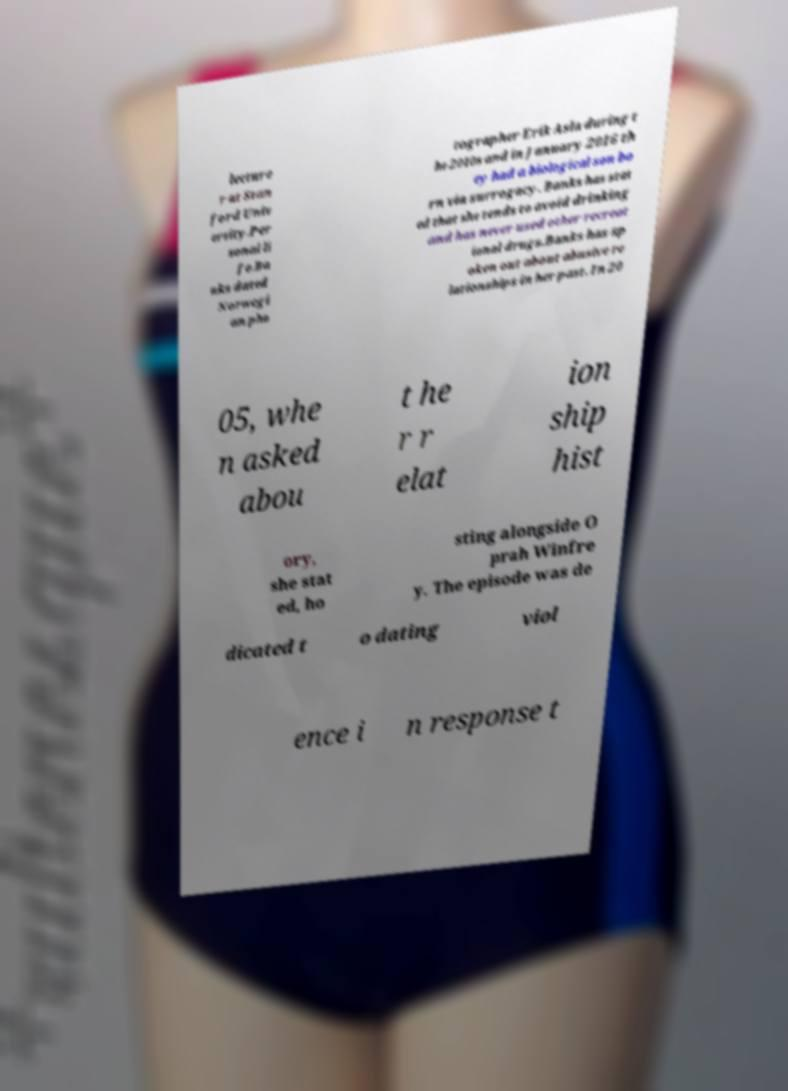Can you read and provide the text displayed in the image?This photo seems to have some interesting text. Can you extract and type it out for me? lecture r at Stan ford Univ ersity.Per sonal li fe.Ba nks dated Norwegi an pho tographer Erik Asla during t he 2010s and in January 2016 th ey had a biological son bo rn via surrogacy. Banks has stat ed that she tends to avoid drinking and has never used other recreat ional drugs.Banks has sp oken out about abusive re lationships in her past. In 20 05, whe n asked abou t he r r elat ion ship hist ory, she stat ed, ho sting alongside O prah Winfre y. The episode was de dicated t o dating viol ence i n response t 